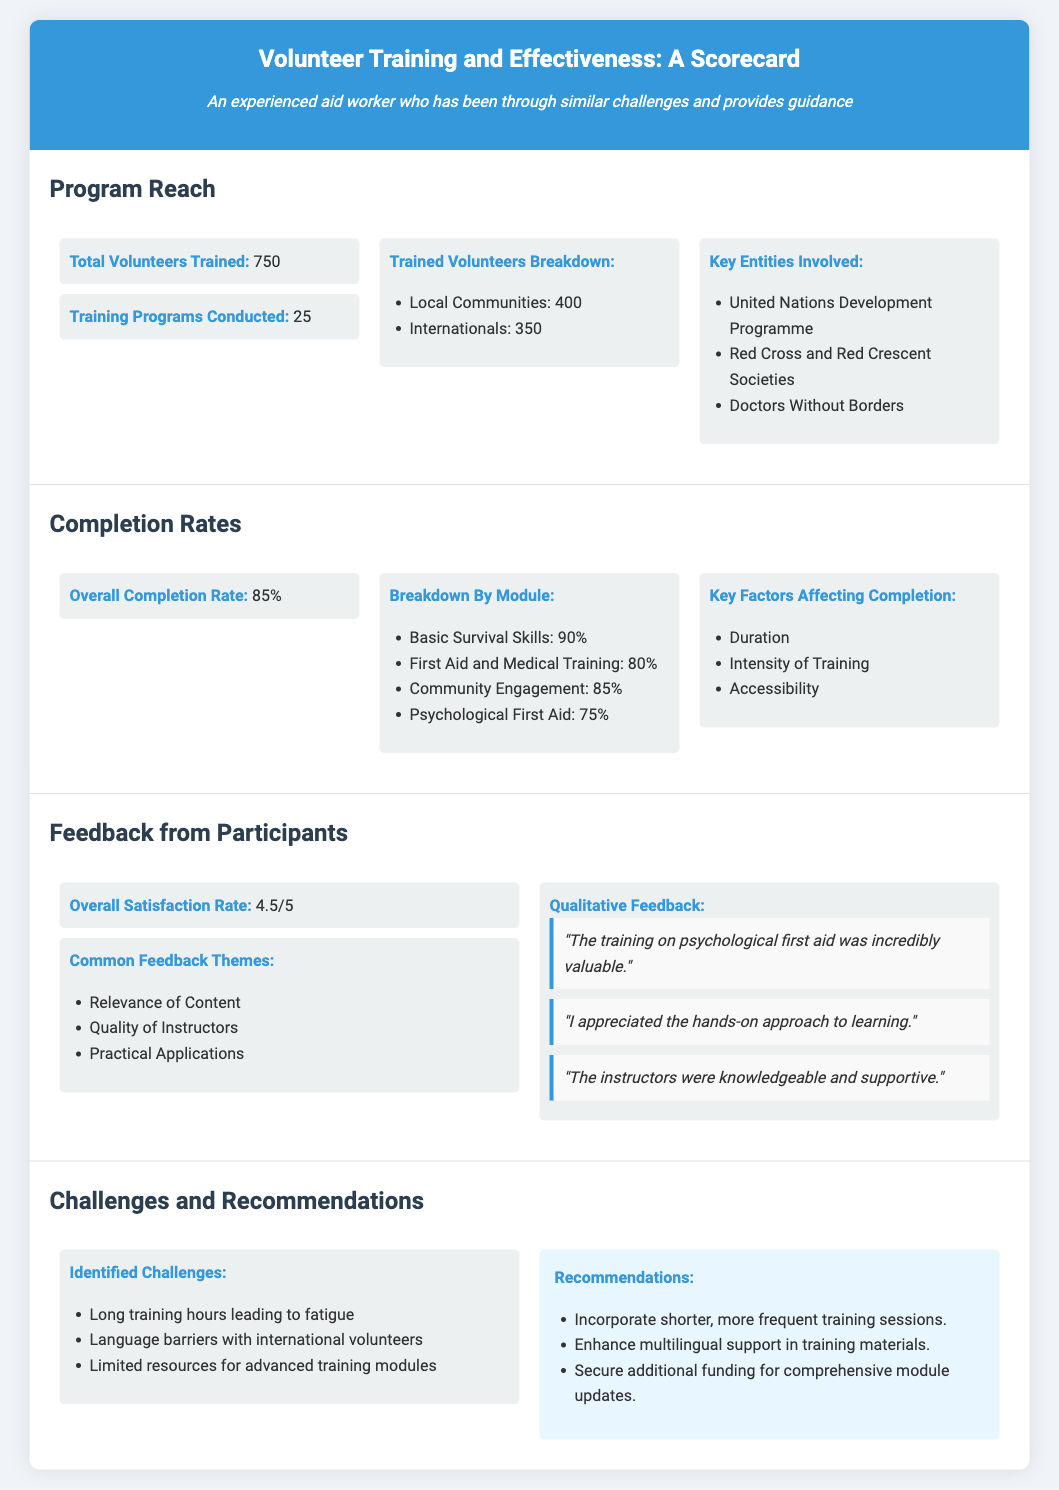What is the total number of volunteers trained? The total number of volunteers trained is listed in the "Program Reach" section of the document.
Answer: 750 What is the overall completion rate of the training programs? The overall completion rate is provided in the "Completion Rates" section of the benchmark.
Answer: 85% How many training programs were conducted? The number of training programs conducted can be found in the "Program Reach" section of the document.
Answer: 25 What is the overall satisfaction rate from participants? The overall satisfaction rate is found in the "Feedback from Participants" section of the scorecard.
Answer: 4.5/5 Which training module has the highest completion rate? The highest completion rate is mentioned in the "Completion Rates" section and requires comparing the rates provided in the document.
Answer: Basic Survival Skills What were the common themes in participant feedback? The recurring themes in participant feedback can be found in the "Feedback from Participants" section.
Answer: Relevance of Content, Quality of Instructors, Practical Applications What are the identified challenges in the training programs? The challenges faced during the training programs are outlined in the "Challenges and Recommendations" section.
Answer: Long training hours, Language barriers, Limited resources What recommendations were made to address the challenges? Recommendations to overcome challenges are presented in the "Challenges and Recommendations" section of the scorecard.
Answer: Incorporate shorter sessions, Enhance multilingual support, Secure additional funding 